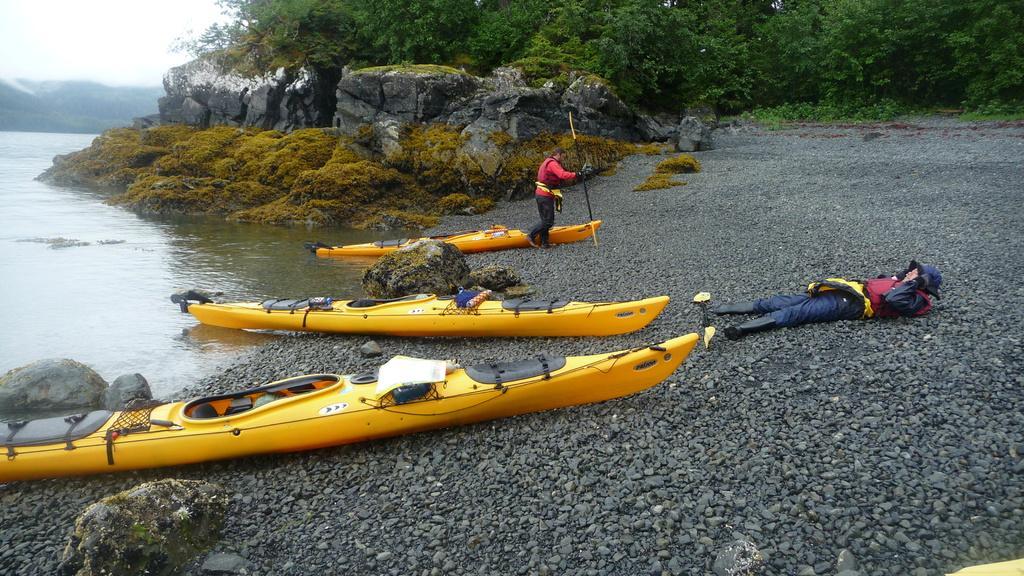In one or two sentences, can you explain what this image depicts? In this image I can see few boats, they are in yellow color and I can also see two persons. The person in front is wearing red shirt, black pant and holding a stick, background I can see the water, trees in green color and the sky is in white color. 